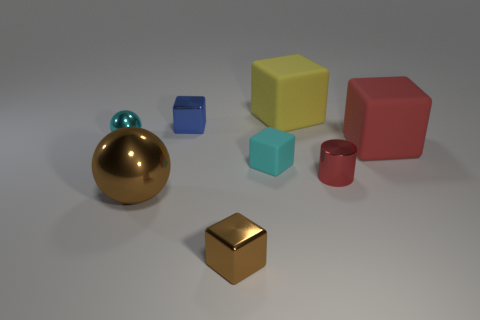Is there anything else that is made of the same material as the large yellow thing?
Offer a terse response. Yes. Is the color of the small metallic sphere the same as the small rubber thing?
Your response must be concise. Yes. The blue object that is made of the same material as the small brown thing is what shape?
Your response must be concise. Cube. What number of big shiny objects have the same shape as the small cyan rubber thing?
Provide a succinct answer. 0. What is the shape of the large thing that is to the left of the metallic cube in front of the small cylinder?
Provide a succinct answer. Sphere. There is a shiny block that is in front of the cyan sphere; is it the same size as the yellow cube?
Offer a terse response. No. There is a block that is in front of the yellow rubber object and behind the cyan metallic thing; what size is it?
Provide a short and direct response. Small. How many blue metal cylinders are the same size as the blue block?
Offer a very short reply. 0. There is a brown thing that is on the left side of the tiny blue cube; how many cylinders are on the right side of it?
Offer a very short reply. 1. There is a small shiny thing that is in front of the tiny red shiny cylinder; does it have the same color as the small shiny cylinder?
Give a very brief answer. No. 